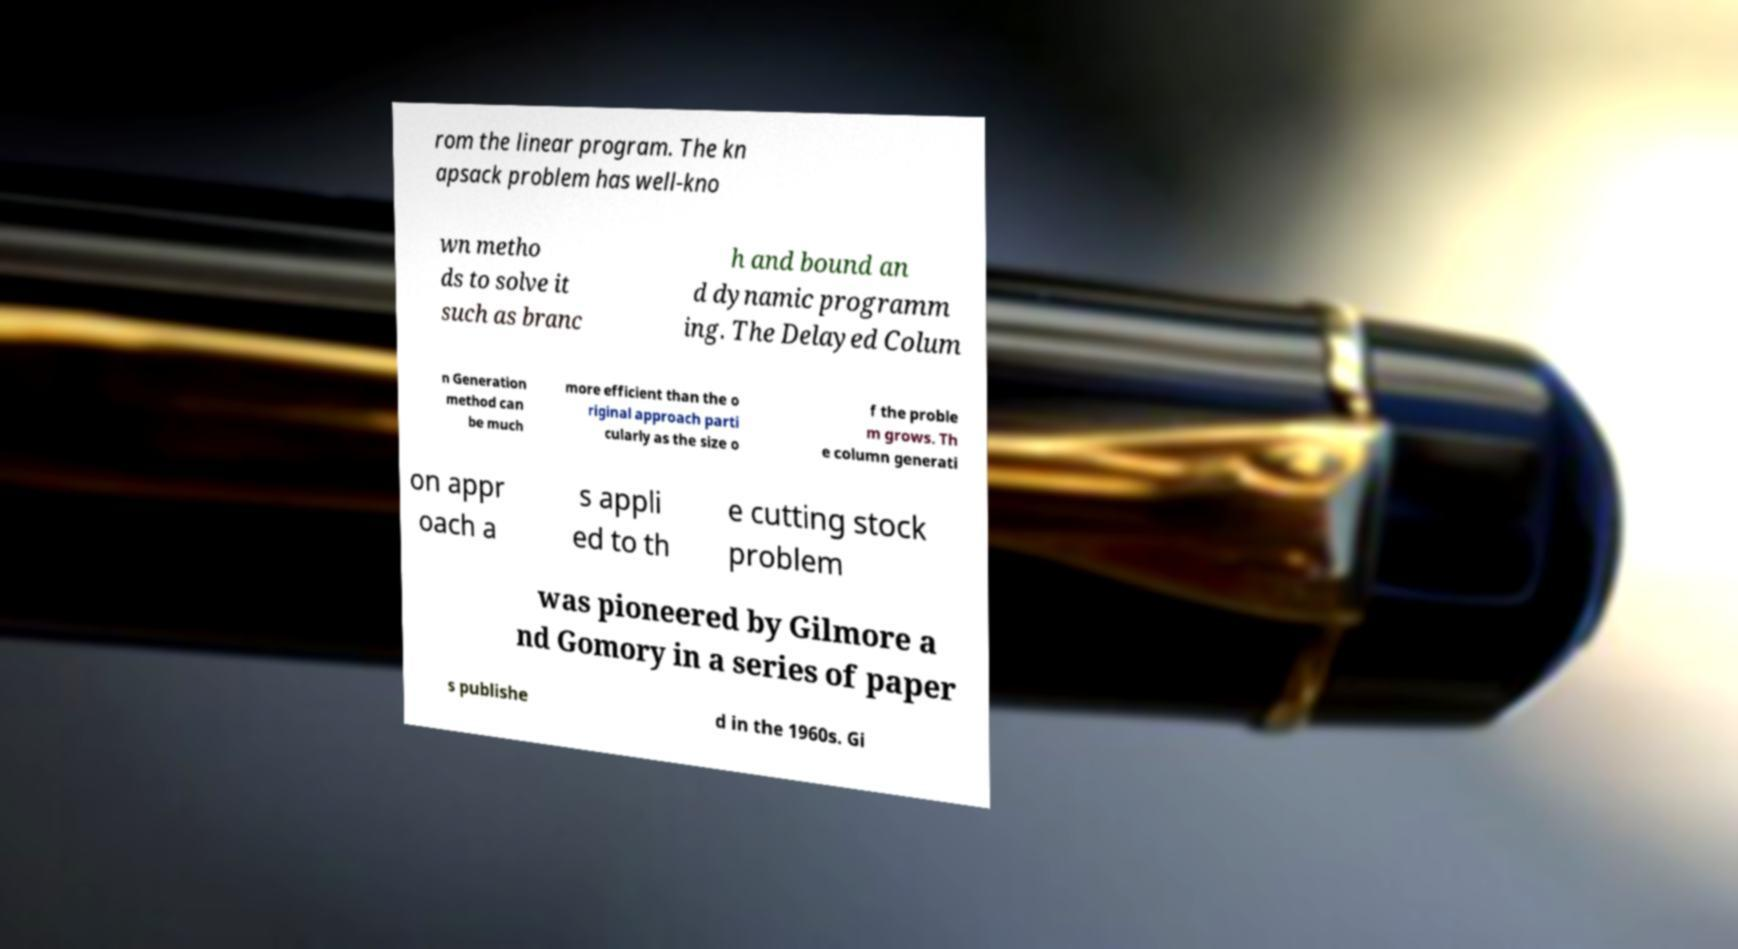Please read and relay the text visible in this image. What does it say? rom the linear program. The kn apsack problem has well-kno wn metho ds to solve it such as branc h and bound an d dynamic programm ing. The Delayed Colum n Generation method can be much more efficient than the o riginal approach parti cularly as the size o f the proble m grows. Th e column generati on appr oach a s appli ed to th e cutting stock problem was pioneered by Gilmore a nd Gomory in a series of paper s publishe d in the 1960s. Gi 